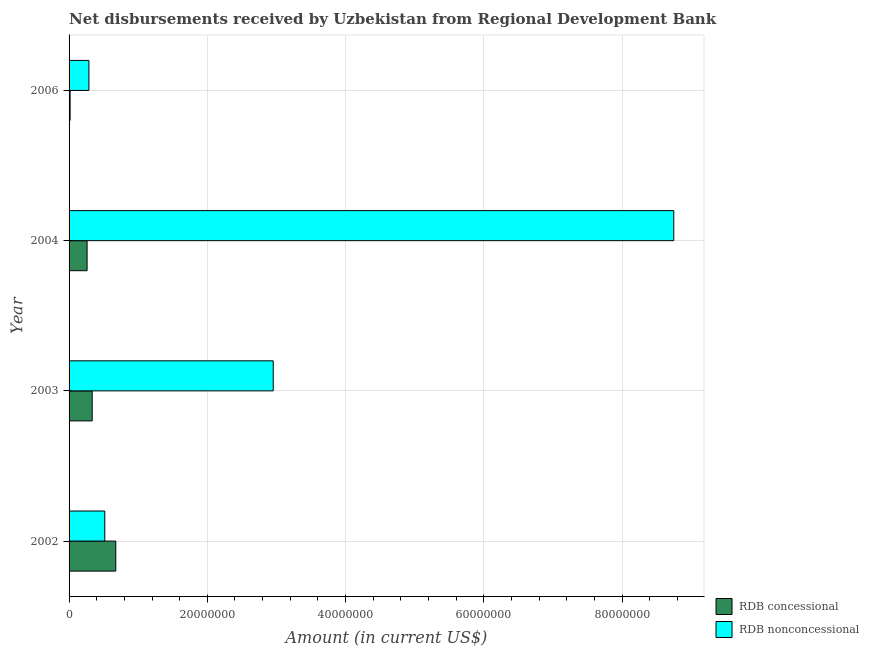How many groups of bars are there?
Provide a succinct answer. 4. Are the number of bars per tick equal to the number of legend labels?
Ensure brevity in your answer.  Yes. Are the number of bars on each tick of the Y-axis equal?
Give a very brief answer. Yes. What is the label of the 2nd group of bars from the top?
Provide a succinct answer. 2004. In how many cases, is the number of bars for a given year not equal to the number of legend labels?
Provide a short and direct response. 0. What is the net concessional disbursements from rdb in 2006?
Offer a very short reply. 1.50e+05. Across all years, what is the maximum net concessional disbursements from rdb?
Keep it short and to the point. 6.76e+06. Across all years, what is the minimum net concessional disbursements from rdb?
Your answer should be very brief. 1.50e+05. In which year was the net non concessional disbursements from rdb maximum?
Provide a short and direct response. 2004. In which year was the net concessional disbursements from rdb minimum?
Your response must be concise. 2006. What is the total net concessional disbursements from rdb in the graph?
Offer a very short reply. 1.29e+07. What is the difference between the net non concessional disbursements from rdb in 2002 and that in 2004?
Make the answer very short. -8.23e+07. What is the difference between the net concessional disbursements from rdb in 2004 and the net non concessional disbursements from rdb in 2003?
Provide a short and direct response. -2.69e+07. What is the average net non concessional disbursements from rdb per year?
Offer a very short reply. 3.13e+07. In the year 2006, what is the difference between the net non concessional disbursements from rdb and net concessional disbursements from rdb?
Your answer should be compact. 2.72e+06. In how many years, is the net non concessional disbursements from rdb greater than 44000000 US$?
Ensure brevity in your answer.  1. What is the ratio of the net non concessional disbursements from rdb in 2003 to that in 2004?
Your response must be concise. 0.34. What is the difference between the highest and the second highest net concessional disbursements from rdb?
Provide a short and direct response. 3.41e+06. What is the difference between the highest and the lowest net non concessional disbursements from rdb?
Your answer should be very brief. 8.46e+07. Is the sum of the net non concessional disbursements from rdb in 2002 and 2006 greater than the maximum net concessional disbursements from rdb across all years?
Give a very brief answer. Yes. What does the 1st bar from the top in 2002 represents?
Make the answer very short. RDB nonconcessional. What does the 1st bar from the bottom in 2003 represents?
Provide a succinct answer. RDB concessional. Are all the bars in the graph horizontal?
Your response must be concise. Yes. What is the title of the graph?
Ensure brevity in your answer.  Net disbursements received by Uzbekistan from Regional Development Bank. What is the label or title of the Y-axis?
Your response must be concise. Year. What is the Amount (in current US$) of RDB concessional in 2002?
Give a very brief answer. 6.76e+06. What is the Amount (in current US$) in RDB nonconcessional in 2002?
Provide a short and direct response. 5.17e+06. What is the Amount (in current US$) in RDB concessional in 2003?
Ensure brevity in your answer.  3.34e+06. What is the Amount (in current US$) in RDB nonconcessional in 2003?
Provide a short and direct response. 2.95e+07. What is the Amount (in current US$) of RDB concessional in 2004?
Ensure brevity in your answer.  2.61e+06. What is the Amount (in current US$) of RDB nonconcessional in 2004?
Ensure brevity in your answer.  8.75e+07. What is the Amount (in current US$) of RDB concessional in 2006?
Provide a succinct answer. 1.50e+05. What is the Amount (in current US$) of RDB nonconcessional in 2006?
Provide a short and direct response. 2.87e+06. Across all years, what is the maximum Amount (in current US$) in RDB concessional?
Your answer should be very brief. 6.76e+06. Across all years, what is the maximum Amount (in current US$) in RDB nonconcessional?
Offer a terse response. 8.75e+07. Across all years, what is the minimum Amount (in current US$) in RDB concessional?
Make the answer very short. 1.50e+05. Across all years, what is the minimum Amount (in current US$) in RDB nonconcessional?
Ensure brevity in your answer.  2.87e+06. What is the total Amount (in current US$) of RDB concessional in the graph?
Your answer should be very brief. 1.29e+07. What is the total Amount (in current US$) of RDB nonconcessional in the graph?
Provide a short and direct response. 1.25e+08. What is the difference between the Amount (in current US$) in RDB concessional in 2002 and that in 2003?
Provide a succinct answer. 3.41e+06. What is the difference between the Amount (in current US$) of RDB nonconcessional in 2002 and that in 2003?
Your response must be concise. -2.44e+07. What is the difference between the Amount (in current US$) of RDB concessional in 2002 and that in 2004?
Provide a short and direct response. 4.15e+06. What is the difference between the Amount (in current US$) in RDB nonconcessional in 2002 and that in 2004?
Offer a terse response. -8.23e+07. What is the difference between the Amount (in current US$) in RDB concessional in 2002 and that in 2006?
Your response must be concise. 6.61e+06. What is the difference between the Amount (in current US$) in RDB nonconcessional in 2002 and that in 2006?
Your response must be concise. 2.30e+06. What is the difference between the Amount (in current US$) in RDB concessional in 2003 and that in 2004?
Your response must be concise. 7.37e+05. What is the difference between the Amount (in current US$) of RDB nonconcessional in 2003 and that in 2004?
Your answer should be compact. -5.80e+07. What is the difference between the Amount (in current US$) in RDB concessional in 2003 and that in 2006?
Keep it short and to the point. 3.20e+06. What is the difference between the Amount (in current US$) of RDB nonconcessional in 2003 and that in 2006?
Your answer should be very brief. 2.67e+07. What is the difference between the Amount (in current US$) of RDB concessional in 2004 and that in 2006?
Offer a very short reply. 2.46e+06. What is the difference between the Amount (in current US$) of RDB nonconcessional in 2004 and that in 2006?
Offer a terse response. 8.46e+07. What is the difference between the Amount (in current US$) of RDB concessional in 2002 and the Amount (in current US$) of RDB nonconcessional in 2003?
Offer a very short reply. -2.28e+07. What is the difference between the Amount (in current US$) in RDB concessional in 2002 and the Amount (in current US$) in RDB nonconcessional in 2004?
Your answer should be very brief. -8.07e+07. What is the difference between the Amount (in current US$) of RDB concessional in 2002 and the Amount (in current US$) of RDB nonconcessional in 2006?
Make the answer very short. 3.89e+06. What is the difference between the Amount (in current US$) of RDB concessional in 2003 and the Amount (in current US$) of RDB nonconcessional in 2004?
Offer a terse response. -8.41e+07. What is the difference between the Amount (in current US$) in RDB concessional in 2003 and the Amount (in current US$) in RDB nonconcessional in 2006?
Provide a short and direct response. 4.74e+05. What is the difference between the Amount (in current US$) of RDB concessional in 2004 and the Amount (in current US$) of RDB nonconcessional in 2006?
Your answer should be compact. -2.63e+05. What is the average Amount (in current US$) in RDB concessional per year?
Your answer should be compact. 3.22e+06. What is the average Amount (in current US$) of RDB nonconcessional per year?
Your response must be concise. 3.13e+07. In the year 2002, what is the difference between the Amount (in current US$) in RDB concessional and Amount (in current US$) in RDB nonconcessional?
Make the answer very short. 1.59e+06. In the year 2003, what is the difference between the Amount (in current US$) in RDB concessional and Amount (in current US$) in RDB nonconcessional?
Provide a short and direct response. -2.62e+07. In the year 2004, what is the difference between the Amount (in current US$) in RDB concessional and Amount (in current US$) in RDB nonconcessional?
Your answer should be compact. -8.49e+07. In the year 2006, what is the difference between the Amount (in current US$) of RDB concessional and Amount (in current US$) of RDB nonconcessional?
Keep it short and to the point. -2.72e+06. What is the ratio of the Amount (in current US$) in RDB concessional in 2002 to that in 2003?
Make the answer very short. 2.02. What is the ratio of the Amount (in current US$) of RDB nonconcessional in 2002 to that in 2003?
Your response must be concise. 0.17. What is the ratio of the Amount (in current US$) in RDB concessional in 2002 to that in 2004?
Keep it short and to the point. 2.59. What is the ratio of the Amount (in current US$) of RDB nonconcessional in 2002 to that in 2004?
Your answer should be compact. 0.06. What is the ratio of the Amount (in current US$) in RDB concessional in 2002 to that in 2006?
Give a very brief answer. 45.05. What is the ratio of the Amount (in current US$) of RDB nonconcessional in 2002 to that in 2006?
Keep it short and to the point. 1.8. What is the ratio of the Amount (in current US$) in RDB concessional in 2003 to that in 2004?
Ensure brevity in your answer.  1.28. What is the ratio of the Amount (in current US$) in RDB nonconcessional in 2003 to that in 2004?
Keep it short and to the point. 0.34. What is the ratio of the Amount (in current US$) of RDB concessional in 2003 to that in 2006?
Your answer should be compact. 22.3. What is the ratio of the Amount (in current US$) of RDB nonconcessional in 2003 to that in 2006?
Your answer should be very brief. 10.29. What is the ratio of the Amount (in current US$) of RDB concessional in 2004 to that in 2006?
Your answer should be compact. 17.39. What is the ratio of the Amount (in current US$) of RDB nonconcessional in 2004 to that in 2006?
Make the answer very short. 30.47. What is the difference between the highest and the second highest Amount (in current US$) of RDB concessional?
Your response must be concise. 3.41e+06. What is the difference between the highest and the second highest Amount (in current US$) in RDB nonconcessional?
Offer a terse response. 5.80e+07. What is the difference between the highest and the lowest Amount (in current US$) in RDB concessional?
Offer a very short reply. 6.61e+06. What is the difference between the highest and the lowest Amount (in current US$) in RDB nonconcessional?
Ensure brevity in your answer.  8.46e+07. 